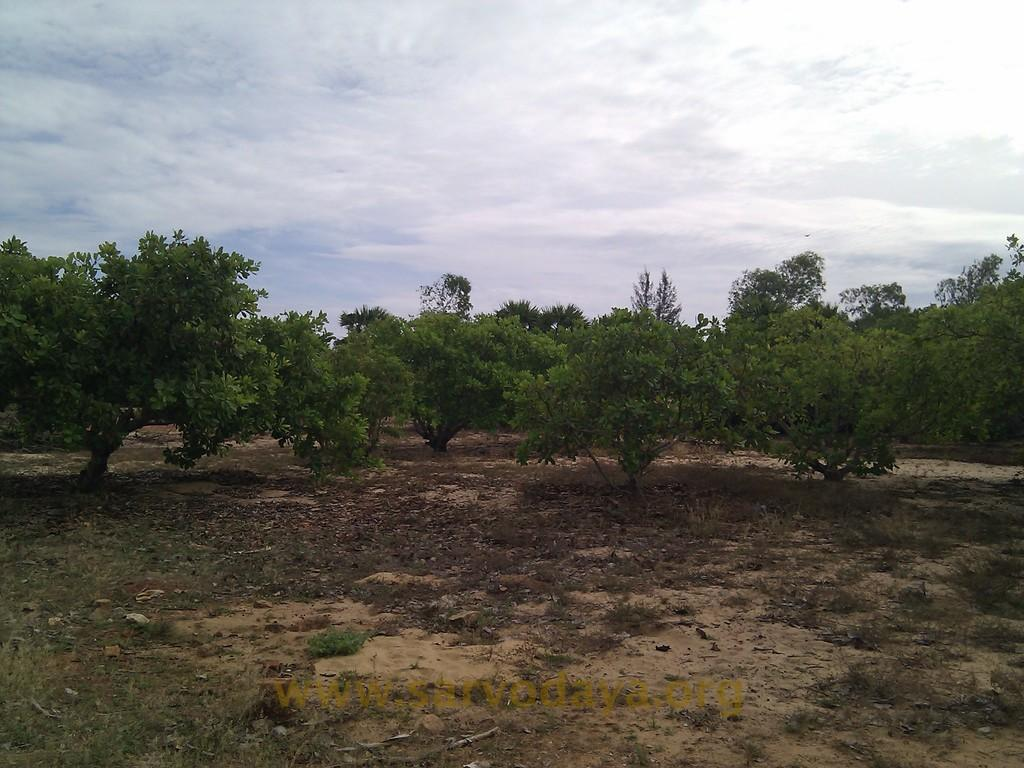What type of vegetation can be seen in the image? There are trees in the image. What part of the natural environment is visible at the bottom of the image? The ground is visible at the bottom of the image. What can be seen in the sky at the top of the image? There are clouds in the sky at the top of the image. What language is spoken by the trees in the image? Trees do not speak any language, so this question cannot be answered. What disease affects the clouds in the image? Clouds do not have diseases, so this question cannot be answered. 